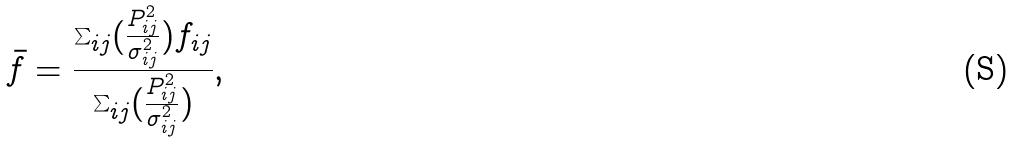Convert formula to latex. <formula><loc_0><loc_0><loc_500><loc_500>\bar { f } = \frac { \sum _ { i j } ( \frac { P _ { i j } ^ { 2 } } { \sigma ^ { 2 } _ { i j } } ) f _ { i j } } { \sum _ { i j } ( \frac { P _ { i j } ^ { 2 } } { \sigma ^ { 2 } _ { i j } } ) } ,</formula> 